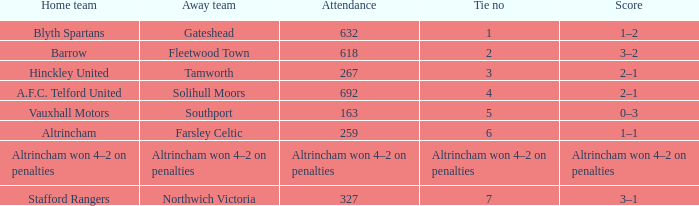Which home team had the away team Southport? Vauxhall Motors. 